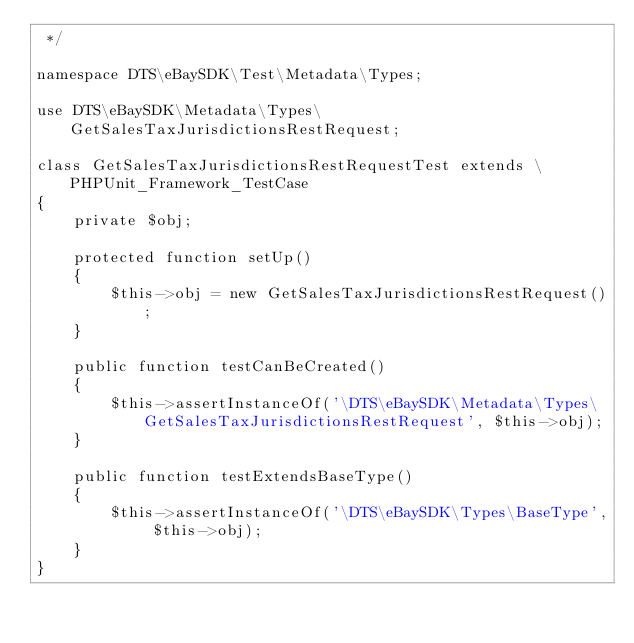<code> <loc_0><loc_0><loc_500><loc_500><_PHP_> */

namespace DTS\eBaySDK\Test\Metadata\Types;

use DTS\eBaySDK\Metadata\Types\GetSalesTaxJurisdictionsRestRequest;

class GetSalesTaxJurisdictionsRestRequestTest extends \PHPUnit_Framework_TestCase
{
    private $obj;

    protected function setUp()
    {
        $this->obj = new GetSalesTaxJurisdictionsRestRequest();
    }

    public function testCanBeCreated()
    {
        $this->assertInstanceOf('\DTS\eBaySDK\Metadata\Types\GetSalesTaxJurisdictionsRestRequest', $this->obj);
    }

    public function testExtendsBaseType()
    {
        $this->assertInstanceOf('\DTS\eBaySDK\Types\BaseType', $this->obj);
    }
}
</code> 